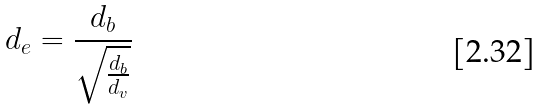<formula> <loc_0><loc_0><loc_500><loc_500>d _ { e } = \frac { d _ { b } } { \sqrt { \frac { d _ { b } } { d _ { v } } } }</formula> 